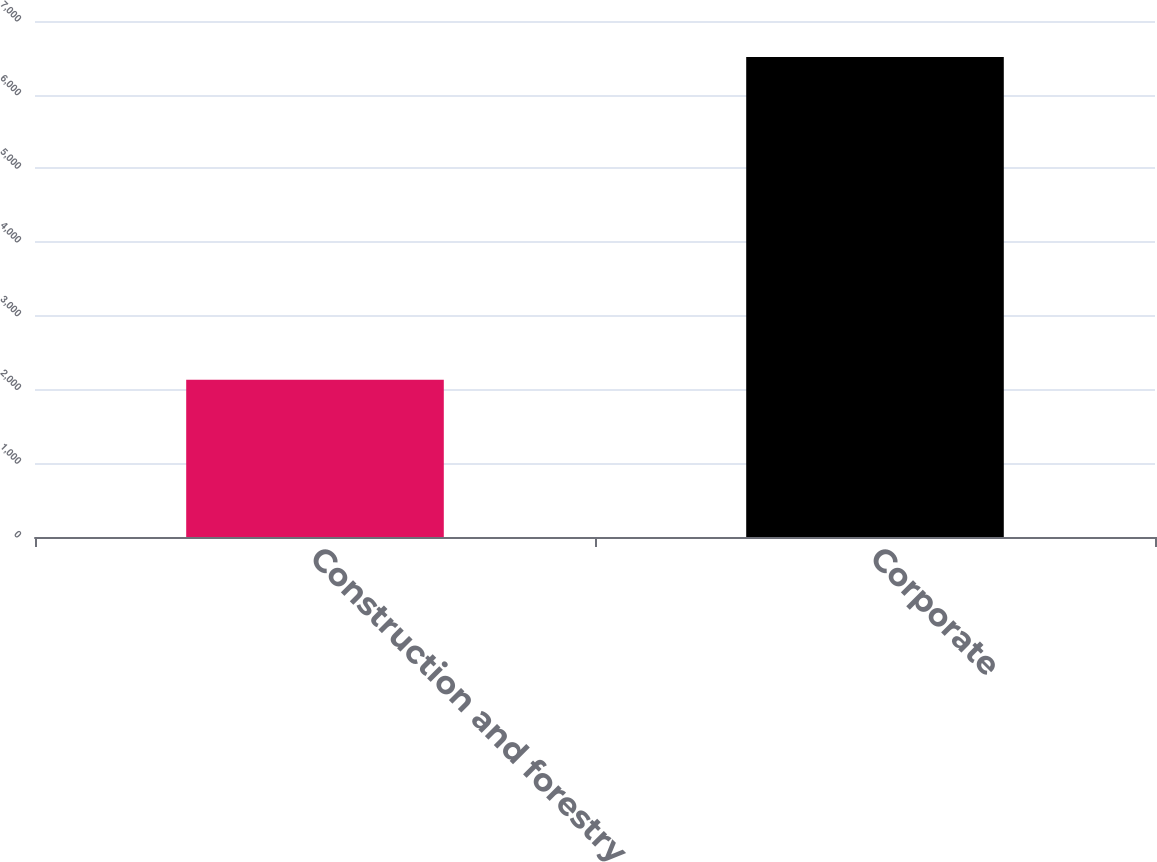<chart> <loc_0><loc_0><loc_500><loc_500><bar_chart><fcel>Construction and forestry<fcel>Corporate<nl><fcel>2132<fcel>6511<nl></chart> 